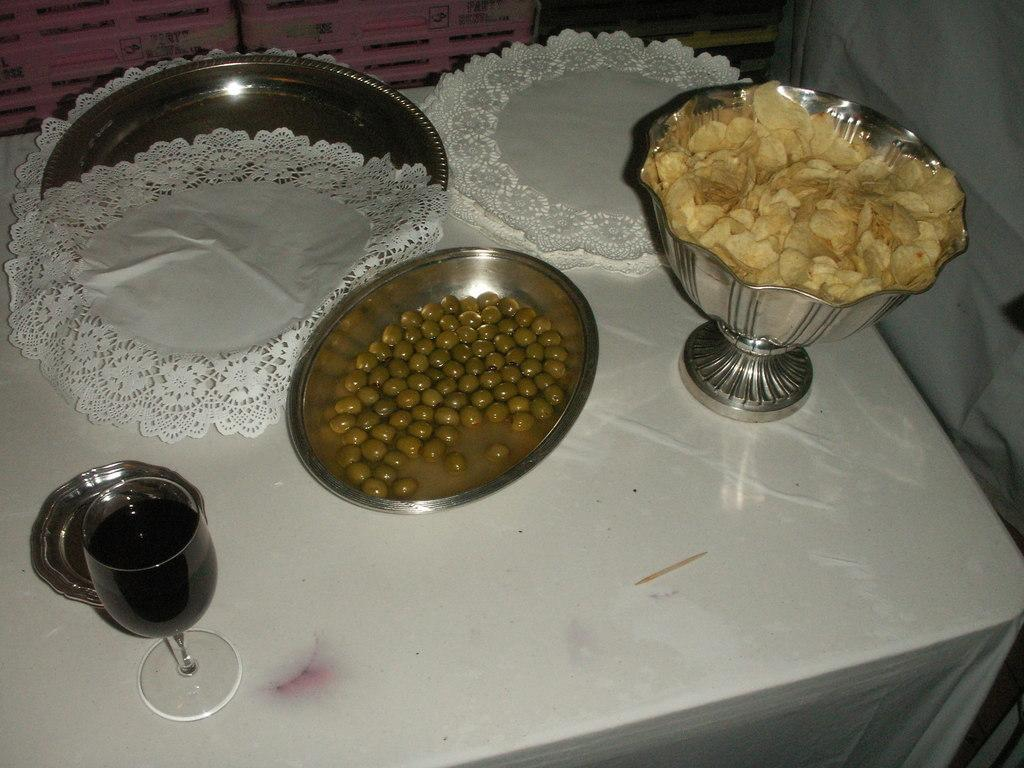What is the main object on the table in the image? There is a plate in the image. What else can be seen beside the plate on the table? There are clothes beside the plate on the table. What type of food is in a bowl on the table? There are chips in a bowl on the table. What other food item is in a separate bowl on the table? There is a food item in another bowl on the table. What beverage is present on the table? There is a glass drink on the table. What is the size of the additional plate on the table? There is a small plate on the table. What type of bread is being served by the sister in the image? There is no sister present in the image, and no bread is visible. 